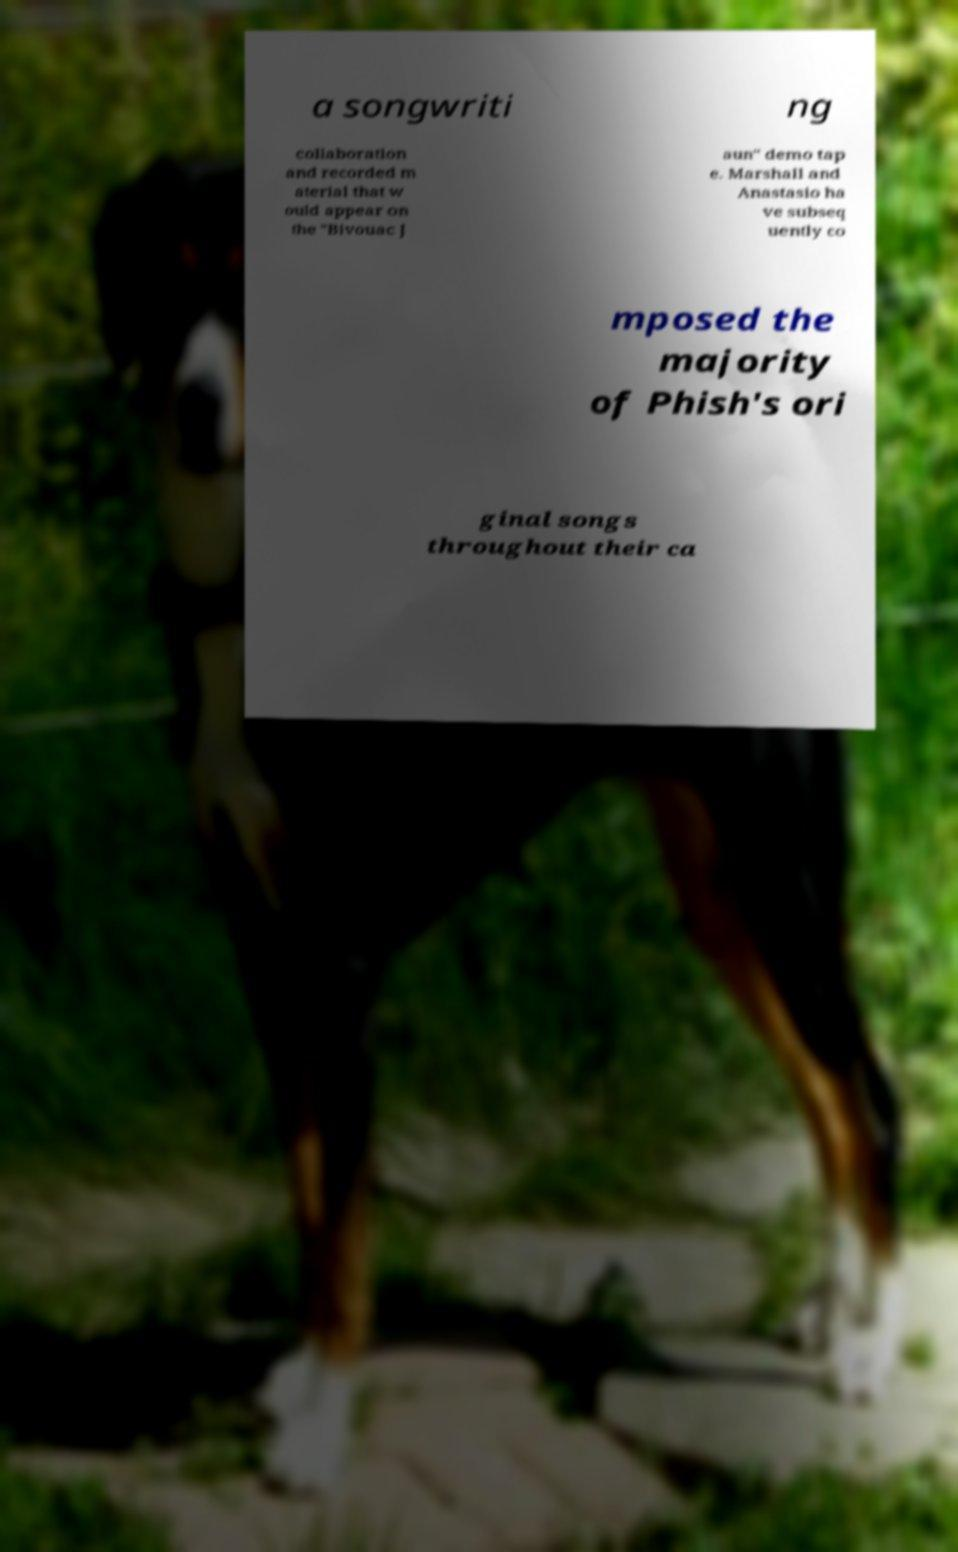There's text embedded in this image that I need extracted. Can you transcribe it verbatim? a songwriti ng collaboration and recorded m aterial that w ould appear on the "Bivouac J aun" demo tap e. Marshall and Anastasio ha ve subseq uently co mposed the majority of Phish's ori ginal songs throughout their ca 